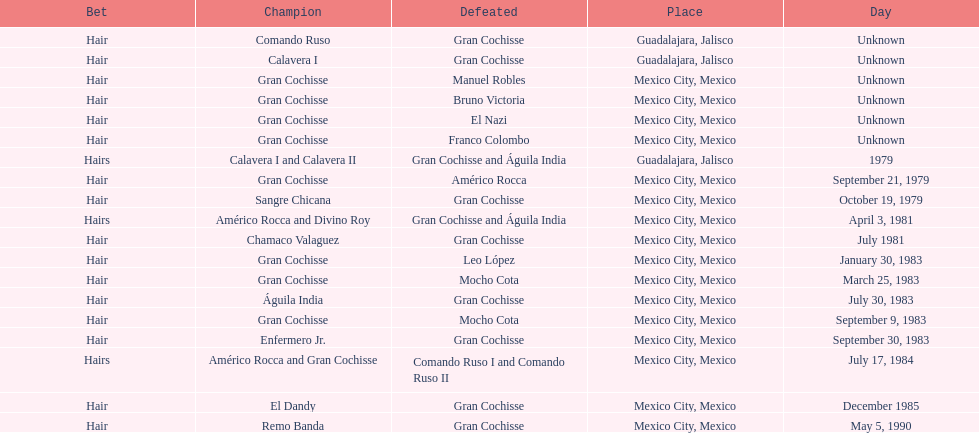How many winners were there before bruno victoria lost? 3. 